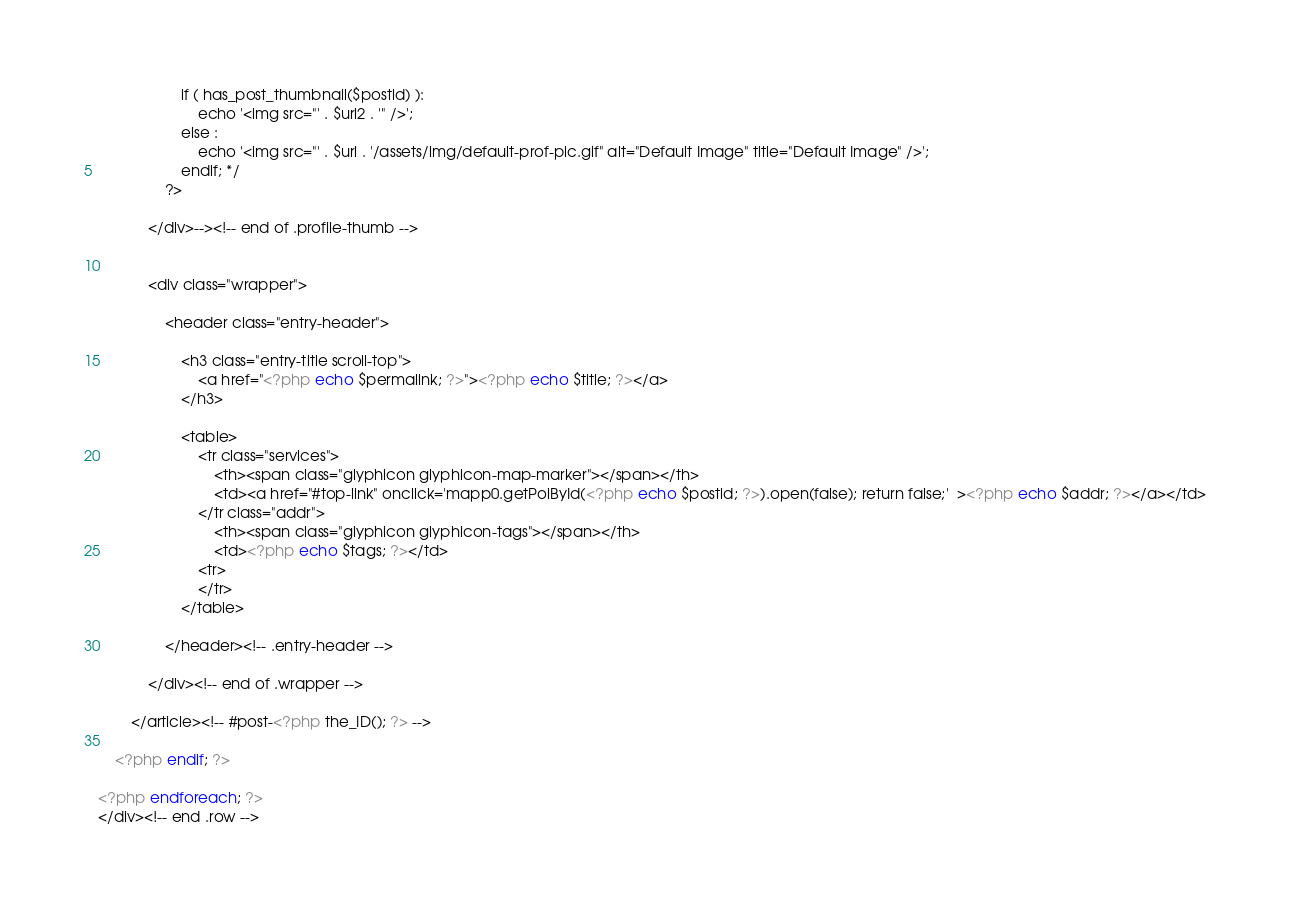Convert code to text. <code><loc_0><loc_0><loc_500><loc_500><_PHP_>					if ( has_post_thumbnail($postid) ):
						echo '<img src="' . $url2 . '" />';			
					else :
						echo '<img src="' . $url . '/assets/img/default-prof-pic.gif" alt="Default Image" title="Default Image" />';
					endif; */	
				?>
		        
		    </div>--><!-- end of .profile-thumb -->
		    
		    
		    <div class="wrapper">
		    
		        <header class="entry-header">
		            
		            <h3 class="entry-title scroll-top">
		            	<a href="<?php echo $permalink; ?>"><?php echo $title; ?></a>
		            </h3>

		            <table>
		            	<tr class="services">
		            		<th><span class="glyphicon glyphicon-map-marker"></span></th>
		            		<td><a href="#top-link" onclick='mapp0.getPoiById(<?php echo $postid; ?>).open(false); return false;'  ><?php echo $addr; ?></a></td>
		            	</tr class="addr">
		            		<th><span class="glyphicon glyphicon-tags"></span></th>
		            		<td><?php echo $tags; ?></td>
		            	<tr>
		            	</tr>
		            </table>

		        </header><!-- .entry-header -->

			</div><!-- end of .wrapper -->

		</article><!-- #post-<?php the_ID(); ?> -->

	<?php endif; ?>

<?php endforeach; ?>
</div><!-- end .row -->

</code> 